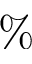Convert formula to latex. <formula><loc_0><loc_0><loc_500><loc_500>\%</formula> 